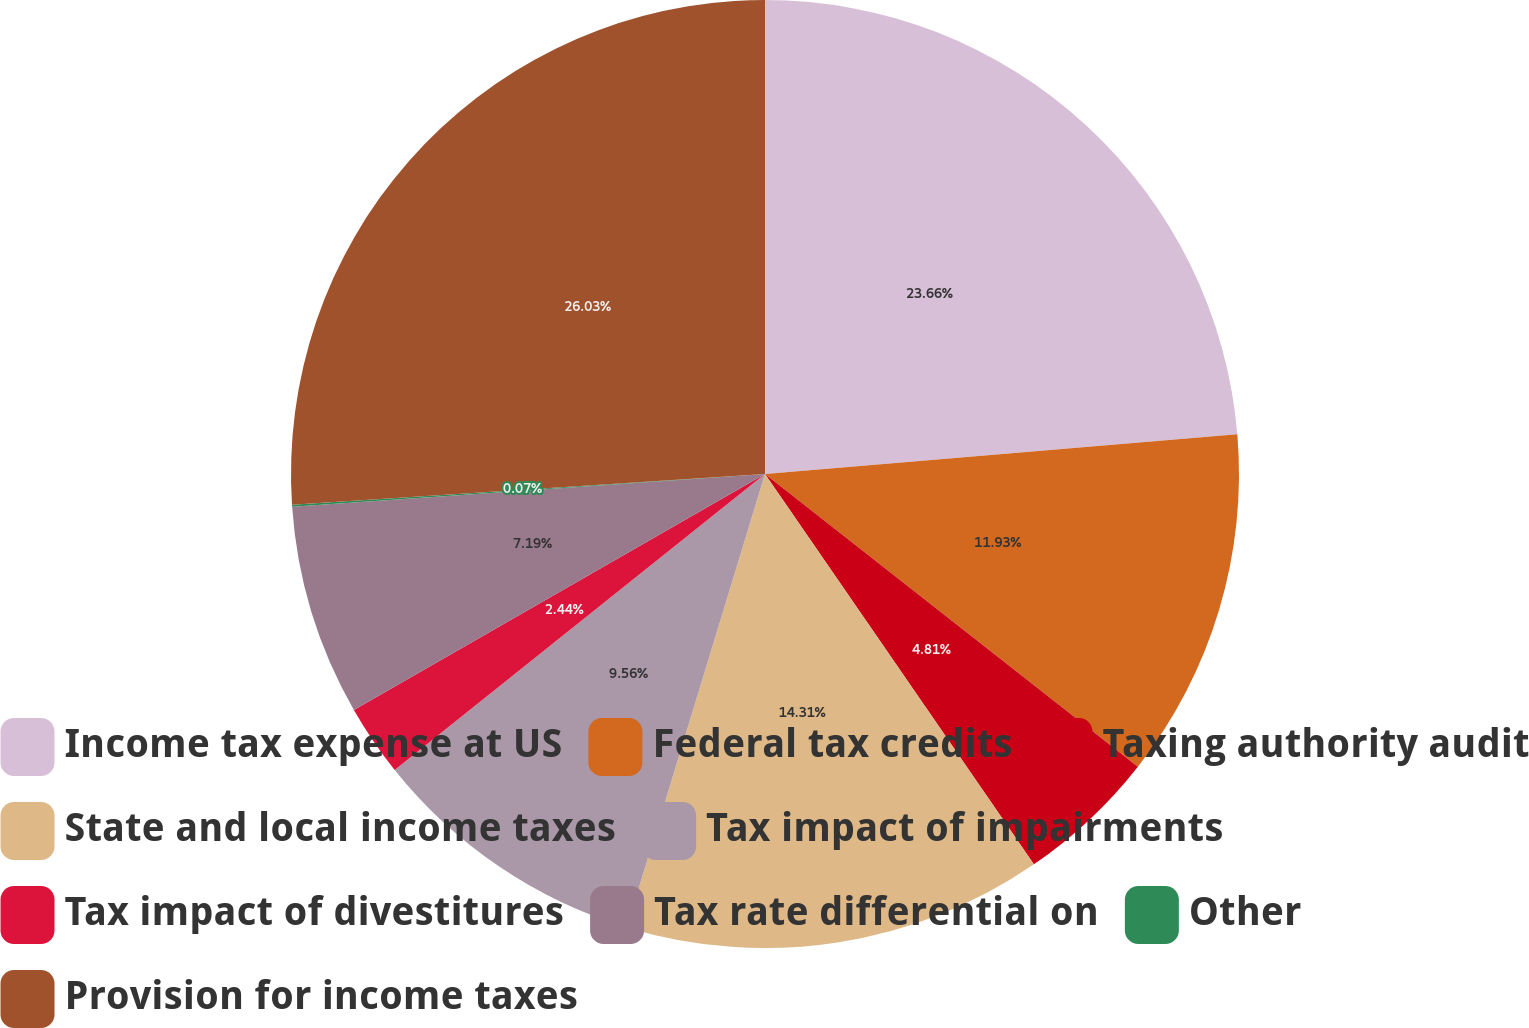Convert chart. <chart><loc_0><loc_0><loc_500><loc_500><pie_chart><fcel>Income tax expense at US<fcel>Federal tax credits<fcel>Taxing authority audit<fcel>State and local income taxes<fcel>Tax impact of impairments<fcel>Tax impact of divestitures<fcel>Tax rate differential on<fcel>Other<fcel>Provision for income taxes<nl><fcel>23.66%<fcel>11.93%<fcel>4.81%<fcel>14.31%<fcel>9.56%<fcel>2.44%<fcel>7.19%<fcel>0.07%<fcel>26.03%<nl></chart> 